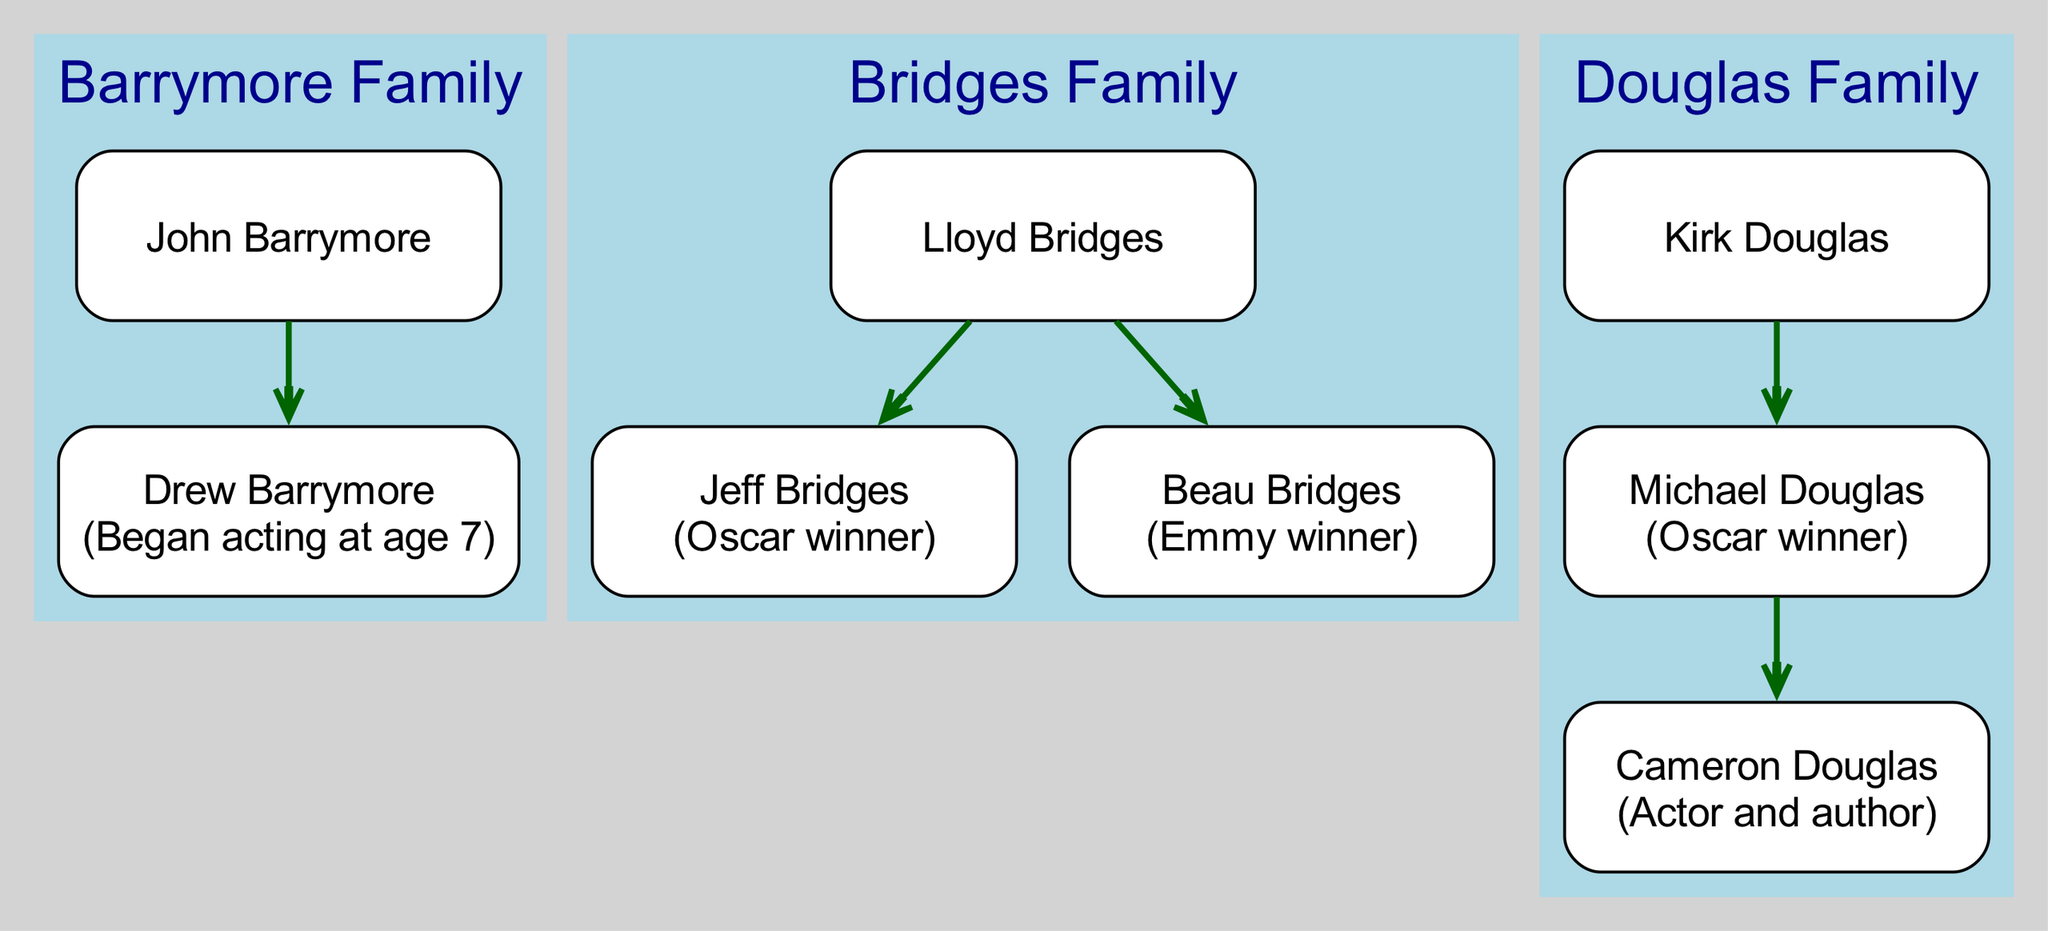How many families are represented in the diagram? The diagram includes three distinct families: Barrymore, Bridges, and Douglas. Each family is enclosed in its own subgraph, clearly indicating the number of families present.
Answer: 3 Who is the child of Kirk Douglas? The diagram shows that Kirk Douglas has one child—Michael Douglas—indicated by an edge leading from Kirk to Michael.
Answer: Michael Douglas Which family has an Oscar winner? Observing the members within each family, it is clear that both Michael Douglas, from the Douglas Family, and Jeff Bridges, from the Bridges Family, are noted as Oscar winners. This indicates that the Bridges Family has an Oscar winner as well.
Answer: Douglas Family and Bridges Family What achievement is associated with Drew Barrymore? In the diagram, it is specified that Drew Barrymore began acting at the age of seven, making it her notable achievement listed under her name in the family tree.
Answer: Began acting at age 7 Which two members are siblings in the Bridges Family? The diagram indicates that Jeff Bridges and Beau Bridges are siblings, as they both directly descend from their father, Lloyd Bridges, represented by lines connecting them as children of Lloyd.
Answer: Jeff Bridges and Beau Bridges How many generations are visible in the Douglas Family? The Douglas Family consists of three generations: Kirk Douglas (the patriarch), his child Michael Douglas, and Michael's child Cameron Douglas. The connections clearly show the lineage, allowing us to count three generations.
Answer: 3 Is there a noted talent in the children of Lloyd Bridges? Both of Lloyd Bridges' children, Jeff and Beau Bridges, have mentioned talents—the former as an Oscar winner and the latter as an Emmy winner. This signifies that both siblings have notable achievements in acting, which can be observed in the diagram.
Answer: Yes What role does Cameron Douglas play in the family tree? In the Douglas Family, Cameron Douglas is portrayed as the child of Michael Douglas, establishing his generational position within the family hierarchy. He is also noted as an actor and author, which is documented next to his name.
Answer: Child of Michael Douglas Which dynasty has the most known achievements? The Douglas Family stands out due to multiple noted achievements: Kirk Douglas, Michael Douglas (Oscar winner), and Cameron Douglas (actor and author). The presence of significant achievements across two generations suggests a higher concentration of recognition.
Answer: Douglas Family 